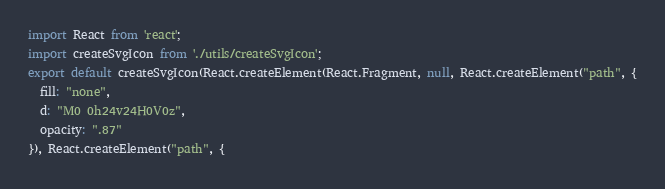<code> <loc_0><loc_0><loc_500><loc_500><_JavaScript_>import React from 'react';
import createSvgIcon from './utils/createSvgIcon';
export default createSvgIcon(React.createElement(React.Fragment, null, React.createElement("path", {
  fill: "none",
  d: "M0 0h24v24H0V0z",
  opacity: ".87"
}), React.createElement("path", {</code> 